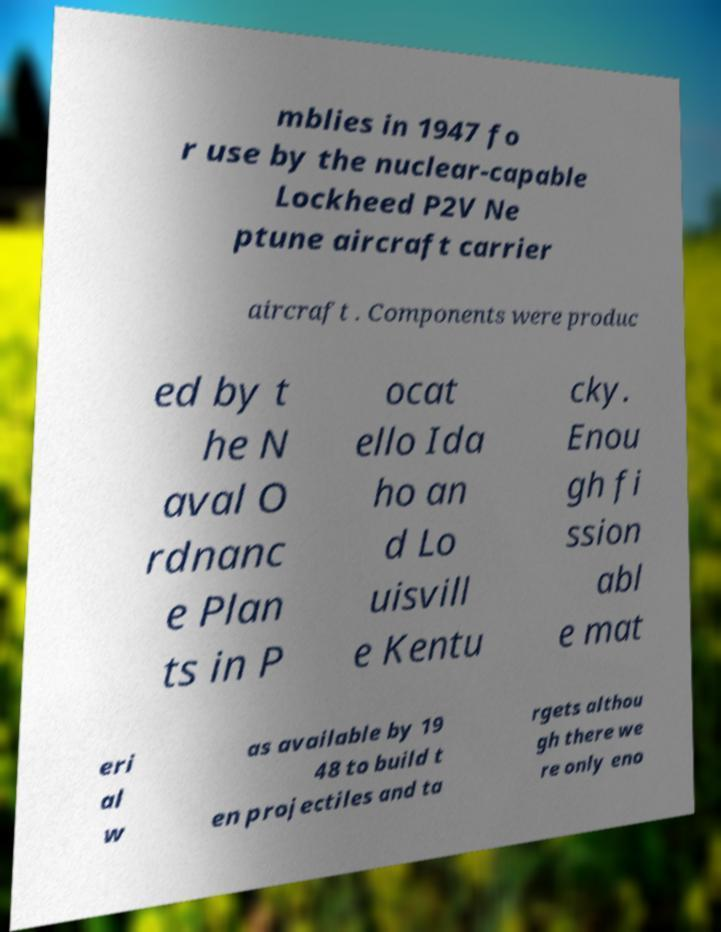I need the written content from this picture converted into text. Can you do that? mblies in 1947 fo r use by the nuclear-capable Lockheed P2V Ne ptune aircraft carrier aircraft . Components were produc ed by t he N aval O rdnanc e Plan ts in P ocat ello Ida ho an d Lo uisvill e Kentu cky. Enou gh fi ssion abl e mat eri al w as available by 19 48 to build t en projectiles and ta rgets althou gh there we re only eno 